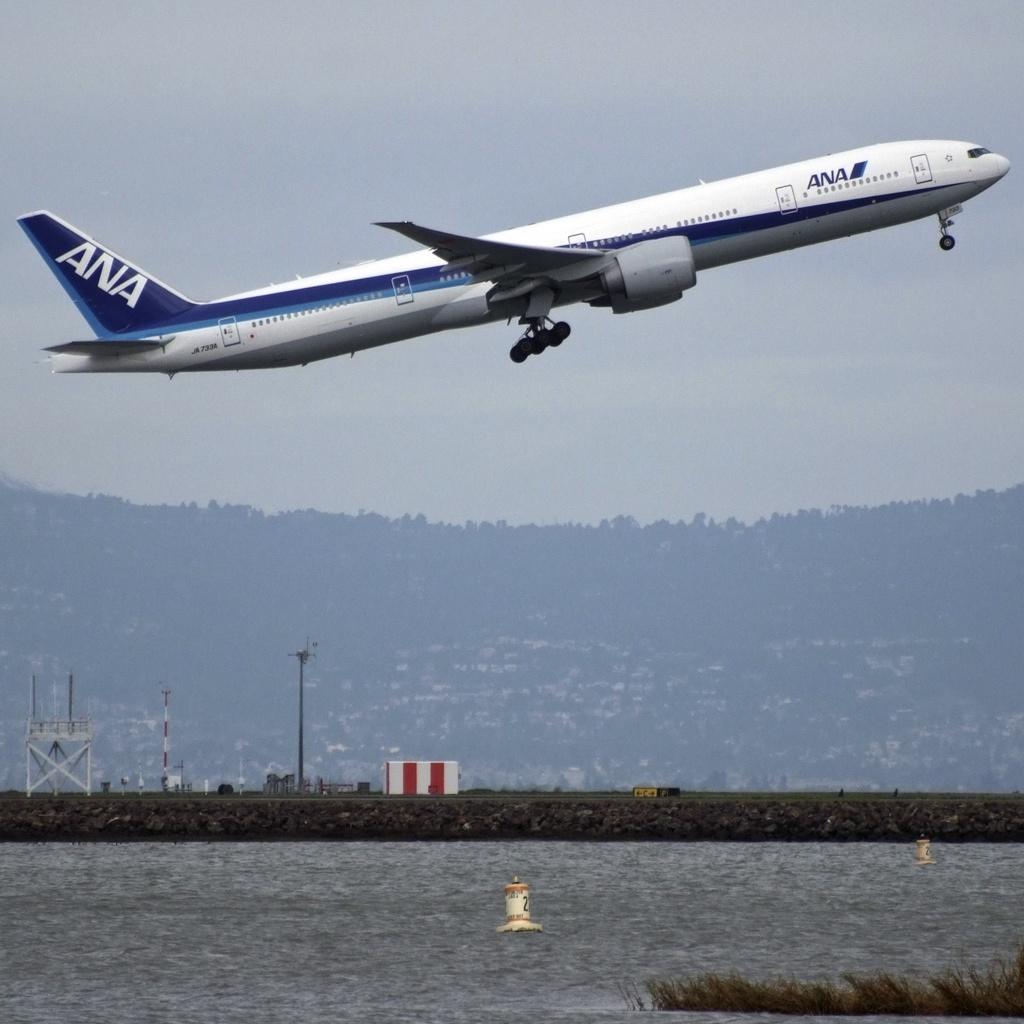What is the name on the tail of this plane?
Your response must be concise. Ana. 